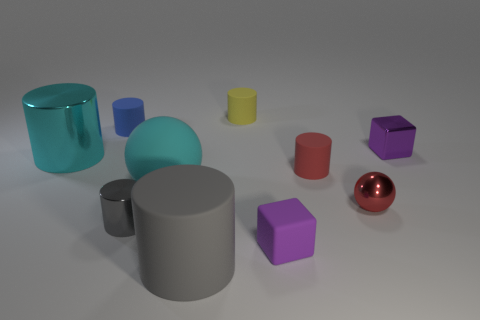Subtract all yellow rubber cylinders. How many cylinders are left? 5 Subtract all brown blocks. How many gray cylinders are left? 2 Subtract all blue cylinders. How many cylinders are left? 5 Subtract 2 cylinders. How many cylinders are left? 4 Subtract all spheres. How many objects are left? 8 Subtract all green cylinders. Subtract all yellow balls. How many cylinders are left? 6 Subtract all tiny red matte spheres. Subtract all tiny purple metal objects. How many objects are left? 9 Add 4 blocks. How many blocks are left? 6 Add 8 large green cubes. How many large green cubes exist? 8 Subtract 1 cyan balls. How many objects are left? 9 